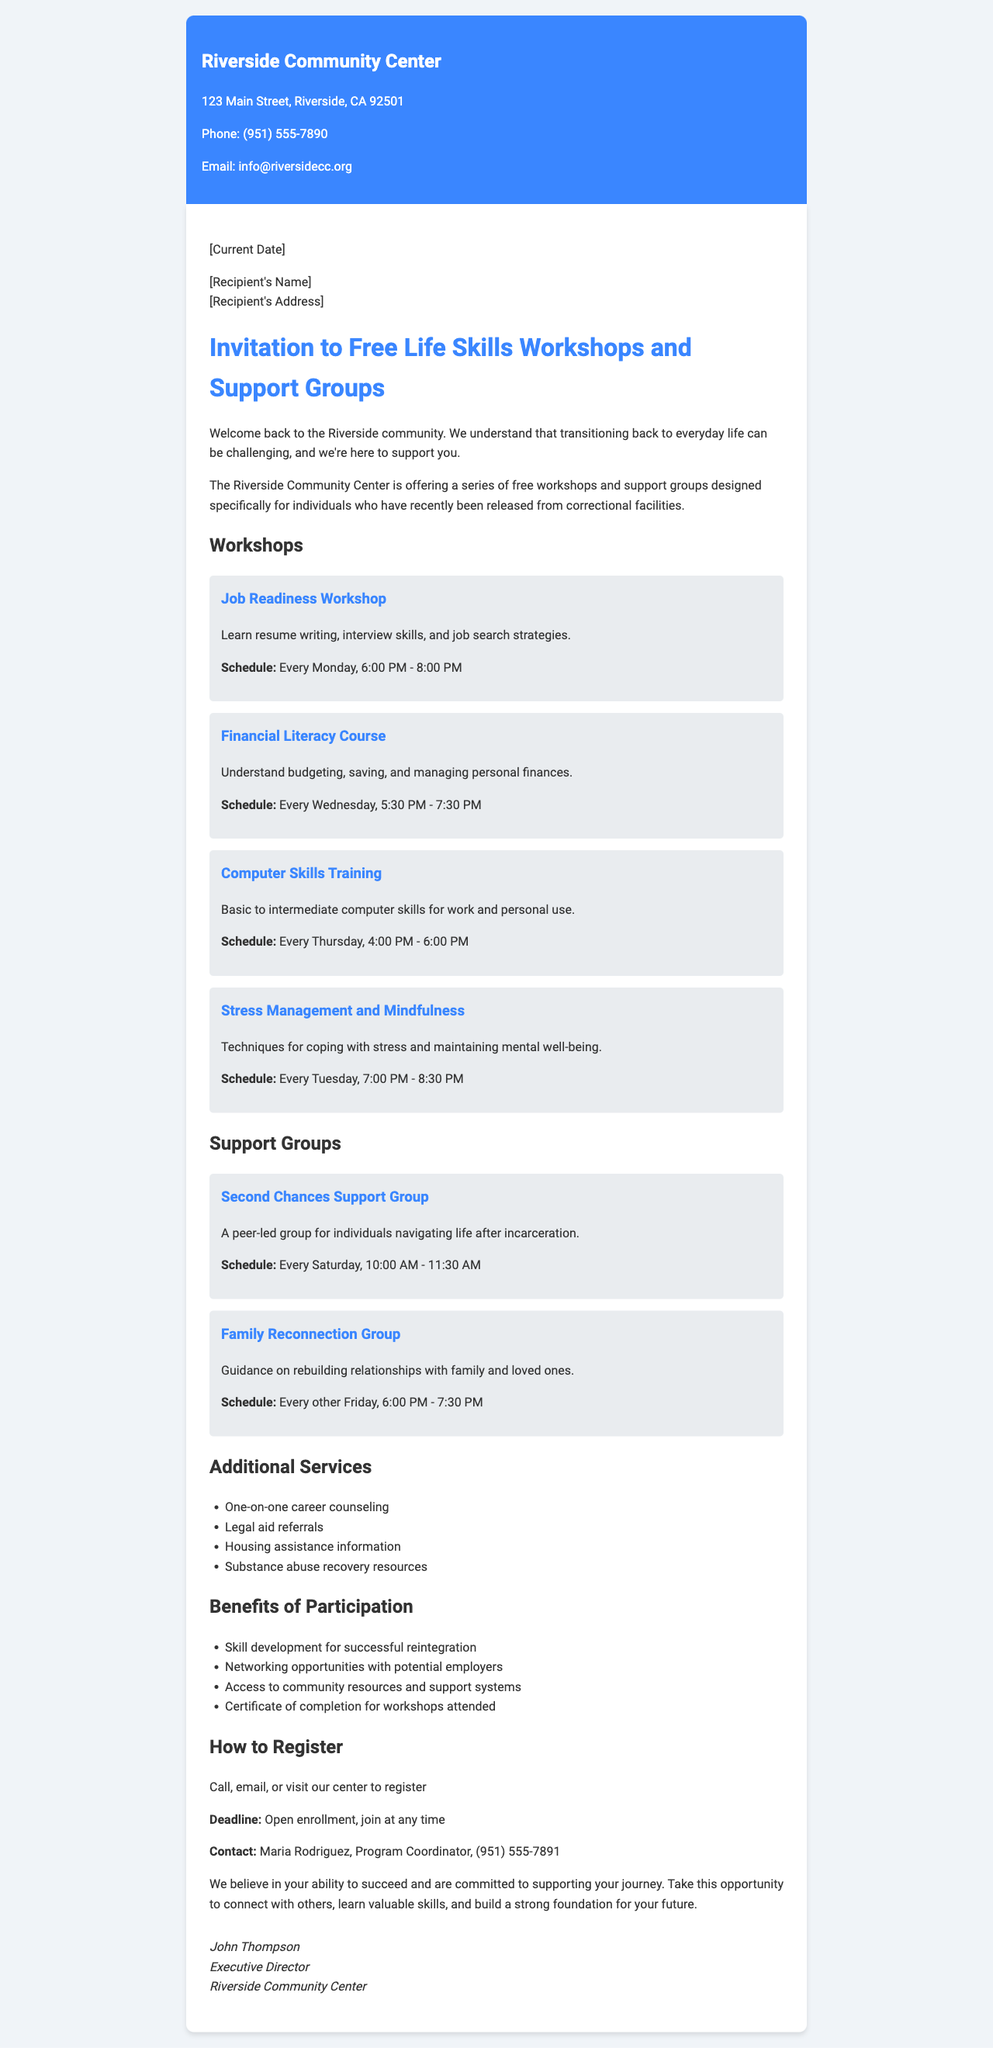What is the name of the sender? The name of the sender is listed at the top of the document.
Answer: Riverside Community Center What is the phone number for the Riverside Community Center? The phone number can be found in the sender's contact information.
Answer: (951) 555-7890 What day and time does the Job Readiness Workshop occur? The schedule for the Job Readiness Workshop is provided in the workshop details section.
Answer: Every Monday, 6:00 PM - 8:00 PM How often does the Second Chances Support Group meet? The meeting frequency of the support group is specified in the support groups section.
Answer: Every Saturday What additional service is provided alongside the workshops? The document lists various support services in the additional services section.
Answer: Housing assistance information Who should be contacted for registration? The contact person for registration is highlighted in the registration information.
Answer: Maria Rodriguez What is a benefit of participating in the workshops? The benefits of participation are outlined in a bulleted list within the document.
Answer: Skill development for successful reintegration When is the enrollment deadline for the workshops? The deadline for enrollment is mentioned in the registration information section.
Answer: Open enrollment, join at any time What is the main purpose of the letter? The purpose is described in the introductory paragraph of the letter.
Answer: Offer free workshops and support groups for individuals recently released from correctional facilities 